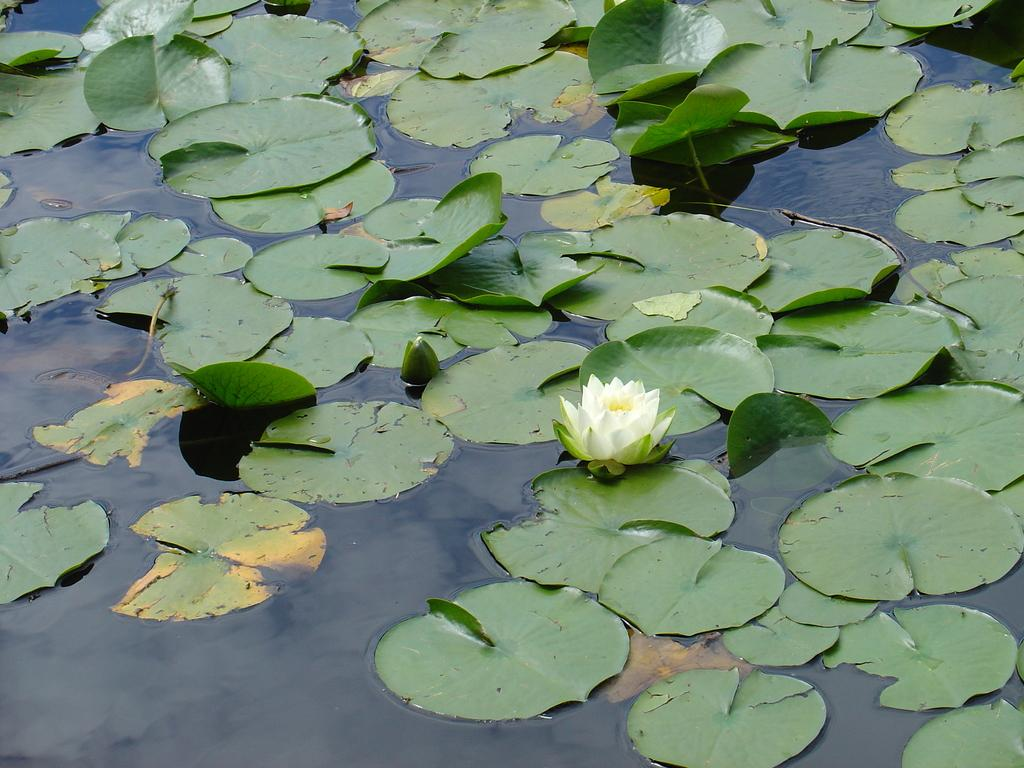What type of plant life is visible in the image? There are leaves and a flower in the image. Where are the leaves and flower located? The leaves and flower are on the water. What type of holiday is being celebrated in the image? There is no indication of a holiday being celebrated in the image. What button is being used to control the movement of the leaves and flower in the image? There is no button or any indication of control over the leaves and flower in the image. 